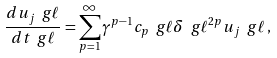<formula> <loc_0><loc_0><loc_500><loc_500>\frac { d u _ { j } \ g \ell } { d t \ g \ell } = \sum _ { p = 1 } ^ { \infty } \gamma ^ { p - 1 } c _ { p } \ g \ell { \delta \ g \ell } ^ { 2 p } u _ { j } \ g \ell \, ,</formula> 